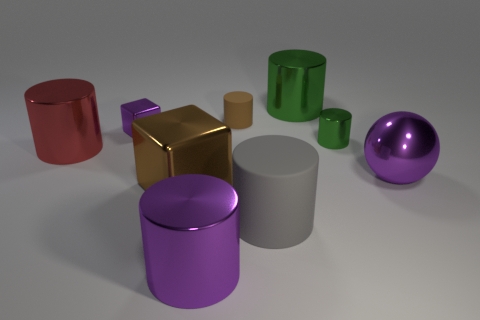How big is the purple shiny object that is behind the gray cylinder and in front of the big red cylinder?
Make the answer very short. Large. What number of other things are there of the same shape as the gray rubber thing?
Your answer should be very brief. 5. There is a large purple metal cylinder; what number of small objects are right of it?
Offer a terse response. 2. Is the number of small metal cylinders left of the red object less than the number of big brown things behind the large matte thing?
Provide a short and direct response. Yes. There is a green metal thing that is in front of the big cylinder behind the large cylinder on the left side of the brown cube; what shape is it?
Provide a short and direct response. Cylinder. What shape is the big shiny object that is in front of the small purple shiny block and right of the large matte thing?
Make the answer very short. Sphere. Are there any large things that have the same material as the small green cylinder?
Your response must be concise. Yes. There is a object that is the same color as the large block; what is its size?
Ensure brevity in your answer.  Small. What color is the shiny cylinder that is left of the large purple shiny cylinder?
Your response must be concise. Red. Does the small rubber object have the same shape as the tiny green metallic thing in front of the big green cylinder?
Make the answer very short. Yes. 